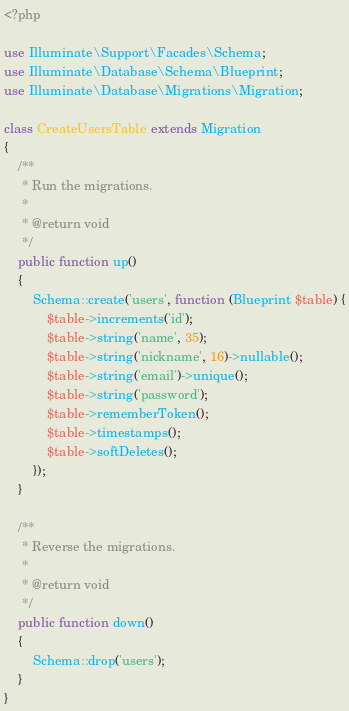Convert code to text. <code><loc_0><loc_0><loc_500><loc_500><_PHP_><?php

use Illuminate\Support\Facades\Schema;
use Illuminate\Database\Schema\Blueprint;
use Illuminate\Database\Migrations\Migration;

class CreateUsersTable extends Migration
{
    /**
     * Run the migrations.
     *
     * @return void
     */
    public function up()
    {
        Schema::create('users', function (Blueprint $table) {
            $table->increments('id');
            $table->string('name', 35);
            $table->string('nickname', 16)->nullable();
            $table->string('email')->unique();
            $table->string('password');
            $table->rememberToken();
            $table->timestamps();
            $table->softDeletes();
        });
    }

    /**
     * Reverse the migrations.
     *
     * @return void
     */
    public function down()
    {
        Schema::drop('users');
    }
}
</code> 